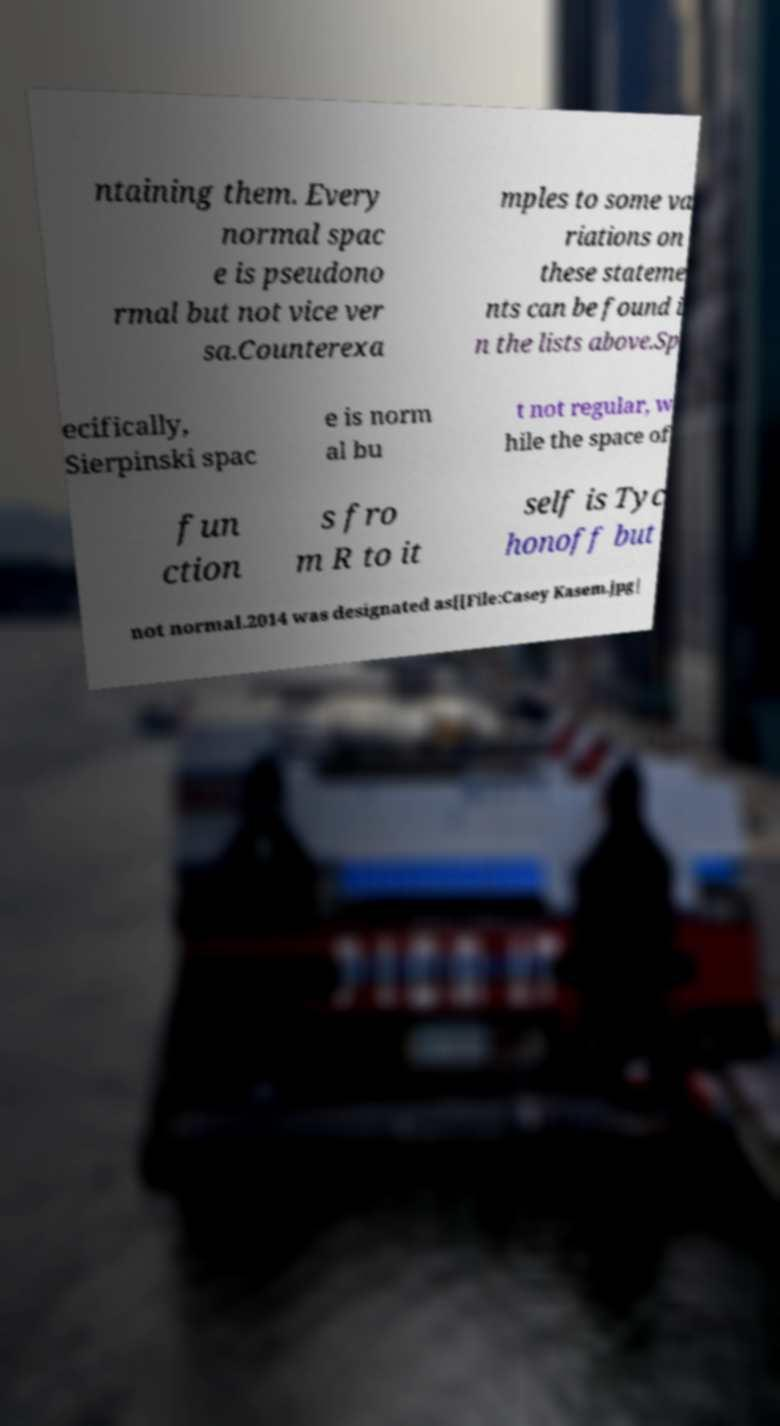There's text embedded in this image that I need extracted. Can you transcribe it verbatim? ntaining them. Every normal spac e is pseudono rmal but not vice ver sa.Counterexa mples to some va riations on these stateme nts can be found i n the lists above.Sp ecifically, Sierpinski spac e is norm al bu t not regular, w hile the space of fun ction s fro m R to it self is Tyc honoff but not normal.2014 was designated as[[File:Casey Kasem.jpg| 